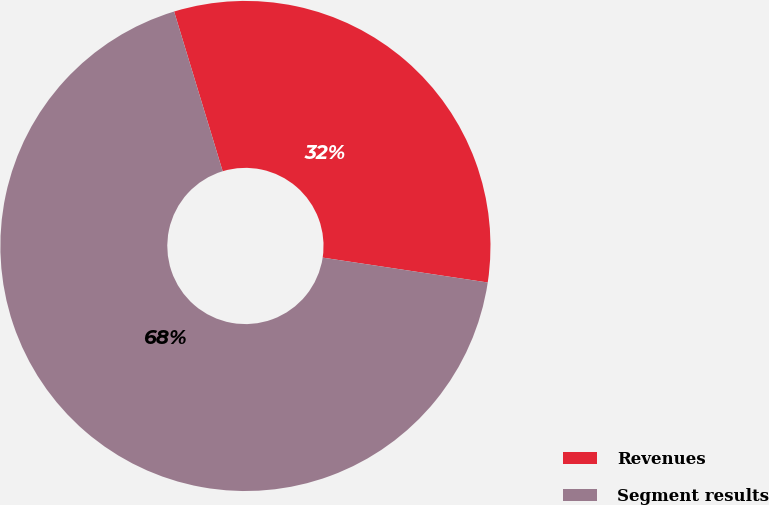Convert chart. <chart><loc_0><loc_0><loc_500><loc_500><pie_chart><fcel>Revenues<fcel>Segment results<nl><fcel>32.08%<fcel>67.92%<nl></chart> 